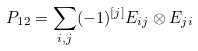Convert formula to latex. <formula><loc_0><loc_0><loc_500><loc_500>P _ { 1 2 } = \sum _ { i , j } ( - 1 ) ^ { [ j ] } E _ { i j } \otimes E _ { j i }</formula> 